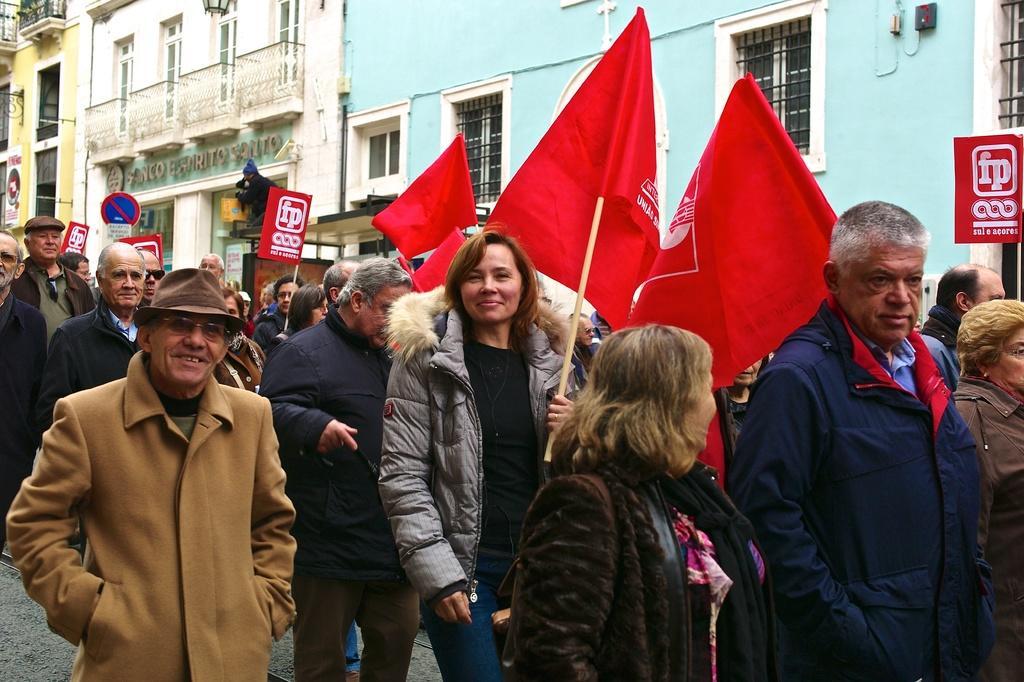How would you summarize this image in a sentence or two? The picture consists of a people holding flags and placards protesting on the street. In the background there are buildings, sign board, windows and other objects. 